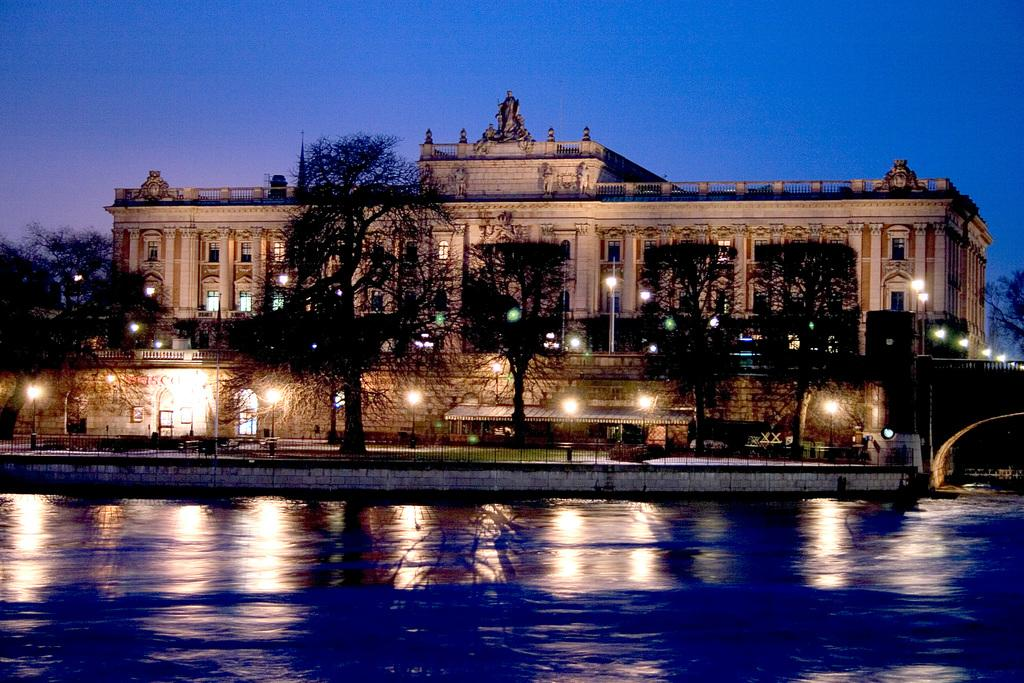What type of vegetation can be seen in the image? There are trees in the image. What can be seen illuminating the area in the image? There are lights in the image. What type of architectural feature is present in the image? There are iron grilles in the image. What decorative elements are present on the building in the image? There are sculptures on the top of a building in the image. What is visible at the bottom of the image? There is water at the bottom of the image. What can be seen in the background of the image? The sky is visible in the background of the image. How many beams can be seen supporting the donkey in the image? There is no donkey or beam present in the image. What type of system is responsible for the water at the bottom of the image? The image does not provide information about a system responsible for the water at the bottom of the image. 